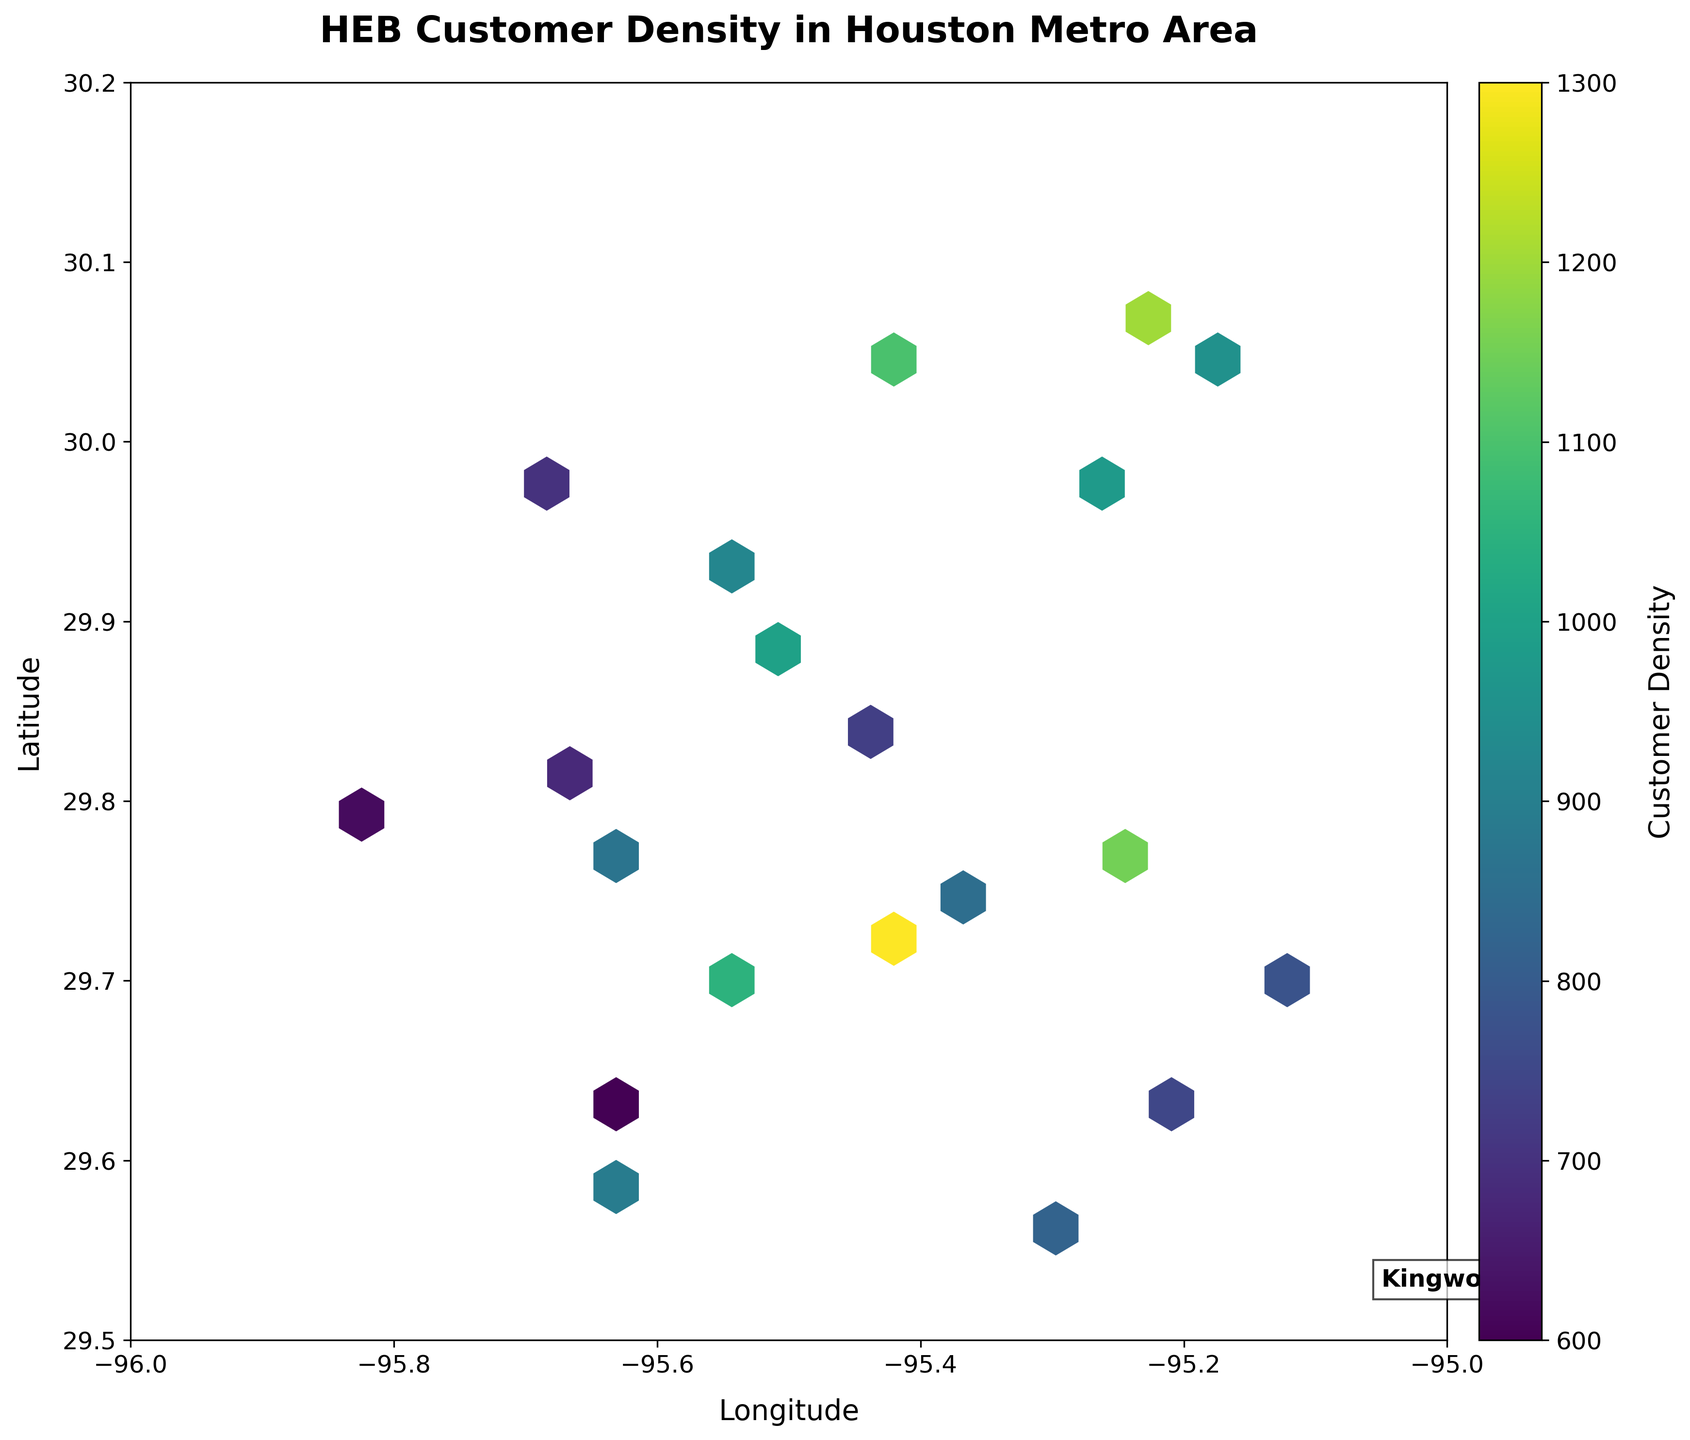What is the title of the figure? The title of the figure is located at the top and is often the most prominent text, designed to provide a quick summary of what the figure is about.
Answer: HEB Customer Density in Houston Metro Area What is the color used to display the customer density? The color indicating customer density is shown on the color spectrum in the color bar, and it ranges from lighter to darker shades. The colormap used here is 'viridis', which spans from yellow to blue-green to purple.
Answer: 'viridis' What geographical area does the plot cover in terms of latitude and longitude? The latitude and longitude ranges can be identified by looking at the axes limits. The latitude ranges from 29.5 to 30.2, while the longitude ranges from -96 to -95.
Answer: Latitude: 29.5 to 30.2, Longitude: -96 to -95 Where is Kingwood located on the plot? The 'Kingwood' label is pinpointed on the plot with a specific geographic annotation in the lower right portion of the plot. The position corresponds to the coordinates of Kingwood within the plot's axes limits.
Answer: Near -95 longitude and 29.53 latitude Which area has the highest customer density? The hexbin plot highlights areas of high customer density with darker colors. The area with the darkest shade indicates the highest customer density.
Answer: Near 29.7230 latitude and -95.4189 longitude What feature indicates the varying levels of customer density? The color bar on the right side of the plot shows a gradient that represents customer density, with different shades corresponding to different density levels.
Answer: Color gradient in the color bar How do the customer densities compare in the northwest versus the southeast of the metro area? Comparing the northwestern and southeastern sections of the plot, the darkness of the hexagons (denoting density) can be inspected. Generally, the northwest seems to have a higher customer density due to the darker hexagons in that region.
Answer: Northwest is denser than southeast What is the customer density range of the lightest-colored hexagons in the plot? The lightest-colored hexagons represent the lowest values on the color bar, which corresponds to the lower limit of the customer density range. This can be found by looking at the color bar labels.
Answer: Around 600-700 Which two nearby areas have significantly different customer densities? To identify nearby areas with different densities, look for adjacent hexagons with contrasting colors. Two such regions can be found where sudden color changes occur in the hexbin plot. One example is between latitudes 29.7604 (downtown) and 30.0688 (northwest).
Answer: Downtown and Northwest What does a white edge around a hexagon signify? The white edge around each hexagon is a stylistic choice to distinguish individual bins more clearly. It does not directly relate to data but improves readability.
Answer: Bin boundary distinction 